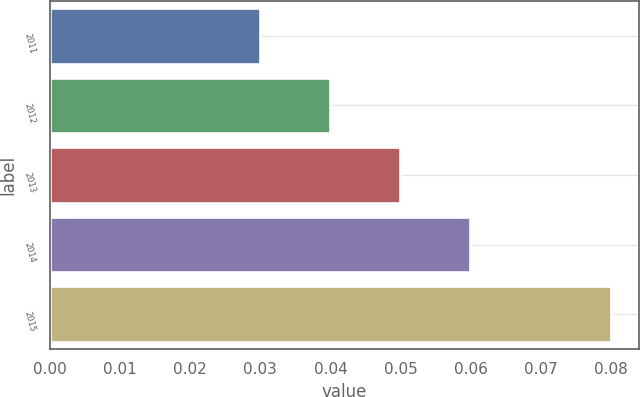Convert chart to OTSL. <chart><loc_0><loc_0><loc_500><loc_500><bar_chart><fcel>2011<fcel>2012<fcel>2013<fcel>2014<fcel>2015<nl><fcel>0.03<fcel>0.04<fcel>0.05<fcel>0.06<fcel>0.08<nl></chart> 